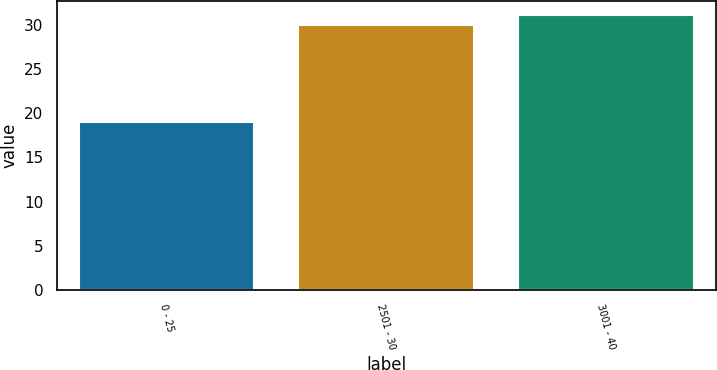<chart> <loc_0><loc_0><loc_500><loc_500><bar_chart><fcel>0 - 25<fcel>2501 - 30<fcel>3001 - 40<nl><fcel>19<fcel>30<fcel>31.2<nl></chart> 